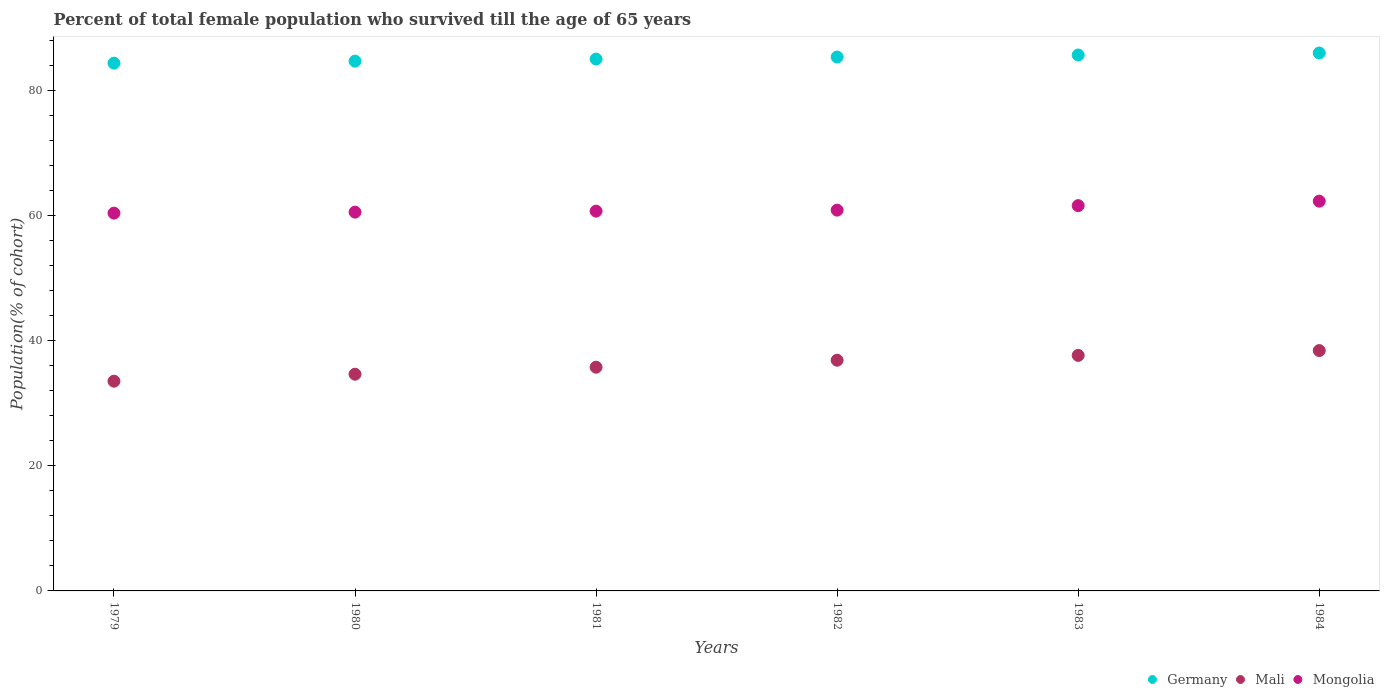What is the percentage of total female population who survived till the age of 65 years in Mongolia in 1982?
Your answer should be compact. 60.85. Across all years, what is the maximum percentage of total female population who survived till the age of 65 years in Germany?
Give a very brief answer. 85.96. Across all years, what is the minimum percentage of total female population who survived till the age of 65 years in Mongolia?
Provide a short and direct response. 60.37. In which year was the percentage of total female population who survived till the age of 65 years in Mali maximum?
Your answer should be very brief. 1984. In which year was the percentage of total female population who survived till the age of 65 years in Germany minimum?
Your answer should be very brief. 1979. What is the total percentage of total female population who survived till the age of 65 years in Mongolia in the graph?
Your response must be concise. 366.28. What is the difference between the percentage of total female population who survived till the age of 65 years in Mongolia in 1981 and that in 1983?
Make the answer very short. -0.88. What is the difference between the percentage of total female population who survived till the age of 65 years in Germany in 1984 and the percentage of total female population who survived till the age of 65 years in Mongolia in 1981?
Offer a very short reply. 25.27. What is the average percentage of total female population who survived till the age of 65 years in Mongolia per year?
Provide a short and direct response. 61.05. In the year 1980, what is the difference between the percentage of total female population who survived till the age of 65 years in Mongolia and percentage of total female population who survived till the age of 65 years in Germany?
Keep it short and to the point. -24.13. In how many years, is the percentage of total female population who survived till the age of 65 years in Germany greater than 4 %?
Ensure brevity in your answer.  6. What is the ratio of the percentage of total female population who survived till the age of 65 years in Mali in 1979 to that in 1983?
Keep it short and to the point. 0.89. Is the difference between the percentage of total female population who survived till the age of 65 years in Mongolia in 1980 and 1983 greater than the difference between the percentage of total female population who survived till the age of 65 years in Germany in 1980 and 1983?
Provide a succinct answer. No. What is the difference between the highest and the second highest percentage of total female population who survived till the age of 65 years in Mali?
Keep it short and to the point. 0.77. What is the difference between the highest and the lowest percentage of total female population who survived till the age of 65 years in Mongolia?
Provide a short and direct response. 1.91. In how many years, is the percentage of total female population who survived till the age of 65 years in Mali greater than the average percentage of total female population who survived till the age of 65 years in Mali taken over all years?
Offer a very short reply. 3. Is the sum of the percentage of total female population who survived till the age of 65 years in Mali in 1982 and 1983 greater than the maximum percentage of total female population who survived till the age of 65 years in Mongolia across all years?
Provide a short and direct response. Yes. Does the percentage of total female population who survived till the age of 65 years in Germany monotonically increase over the years?
Provide a short and direct response. Yes. Is the percentage of total female population who survived till the age of 65 years in Mali strictly greater than the percentage of total female population who survived till the age of 65 years in Germany over the years?
Provide a short and direct response. No. How many dotlines are there?
Your answer should be very brief. 3. What is the difference between two consecutive major ticks on the Y-axis?
Your response must be concise. 20. Does the graph contain grids?
Your answer should be compact. No. How are the legend labels stacked?
Your answer should be very brief. Horizontal. What is the title of the graph?
Provide a succinct answer. Percent of total female population who survived till the age of 65 years. Does "Swaziland" appear as one of the legend labels in the graph?
Keep it short and to the point. No. What is the label or title of the X-axis?
Your answer should be compact. Years. What is the label or title of the Y-axis?
Your response must be concise. Population(% of cohort). What is the Population(% of cohort) of Germany in 1979?
Make the answer very short. 84.33. What is the Population(% of cohort) in Mali in 1979?
Your response must be concise. 33.51. What is the Population(% of cohort) in Mongolia in 1979?
Ensure brevity in your answer.  60.37. What is the Population(% of cohort) of Germany in 1980?
Provide a short and direct response. 84.66. What is the Population(% of cohort) of Mali in 1980?
Your response must be concise. 34.63. What is the Population(% of cohort) of Mongolia in 1980?
Provide a short and direct response. 60.53. What is the Population(% of cohort) in Germany in 1981?
Your response must be concise. 84.99. What is the Population(% of cohort) in Mali in 1981?
Your answer should be very brief. 35.75. What is the Population(% of cohort) of Mongolia in 1981?
Your answer should be very brief. 60.69. What is the Population(% of cohort) of Germany in 1982?
Ensure brevity in your answer.  85.32. What is the Population(% of cohort) of Mali in 1982?
Provide a succinct answer. 36.86. What is the Population(% of cohort) in Mongolia in 1982?
Provide a short and direct response. 60.85. What is the Population(% of cohort) of Germany in 1983?
Provide a short and direct response. 85.64. What is the Population(% of cohort) in Mali in 1983?
Offer a terse response. 37.64. What is the Population(% of cohort) in Mongolia in 1983?
Offer a terse response. 61.56. What is the Population(% of cohort) of Germany in 1984?
Keep it short and to the point. 85.96. What is the Population(% of cohort) in Mali in 1984?
Keep it short and to the point. 38.41. What is the Population(% of cohort) of Mongolia in 1984?
Offer a terse response. 62.28. Across all years, what is the maximum Population(% of cohort) of Germany?
Give a very brief answer. 85.96. Across all years, what is the maximum Population(% of cohort) of Mali?
Provide a succinct answer. 38.41. Across all years, what is the maximum Population(% of cohort) in Mongolia?
Your answer should be compact. 62.28. Across all years, what is the minimum Population(% of cohort) of Germany?
Your answer should be compact. 84.33. Across all years, what is the minimum Population(% of cohort) of Mali?
Offer a terse response. 33.51. Across all years, what is the minimum Population(% of cohort) of Mongolia?
Your answer should be very brief. 60.37. What is the total Population(% of cohort) of Germany in the graph?
Provide a short and direct response. 510.89. What is the total Population(% of cohort) of Mali in the graph?
Offer a terse response. 216.8. What is the total Population(% of cohort) in Mongolia in the graph?
Make the answer very short. 366.28. What is the difference between the Population(% of cohort) in Germany in 1979 and that in 1980?
Your answer should be compact. -0.33. What is the difference between the Population(% of cohort) of Mali in 1979 and that in 1980?
Your answer should be very brief. -1.12. What is the difference between the Population(% of cohort) in Mongolia in 1979 and that in 1980?
Offer a terse response. -0.16. What is the difference between the Population(% of cohort) in Germany in 1979 and that in 1981?
Your response must be concise. -0.66. What is the difference between the Population(% of cohort) in Mali in 1979 and that in 1981?
Ensure brevity in your answer.  -2.23. What is the difference between the Population(% of cohort) in Mongolia in 1979 and that in 1981?
Your answer should be compact. -0.32. What is the difference between the Population(% of cohort) of Germany in 1979 and that in 1982?
Your response must be concise. -0.98. What is the difference between the Population(% of cohort) of Mali in 1979 and that in 1982?
Offer a terse response. -3.35. What is the difference between the Population(% of cohort) of Mongolia in 1979 and that in 1982?
Your answer should be very brief. -0.48. What is the difference between the Population(% of cohort) in Germany in 1979 and that in 1983?
Make the answer very short. -1.31. What is the difference between the Population(% of cohort) in Mali in 1979 and that in 1983?
Your answer should be compact. -4.12. What is the difference between the Population(% of cohort) in Mongolia in 1979 and that in 1983?
Ensure brevity in your answer.  -1.2. What is the difference between the Population(% of cohort) in Germany in 1979 and that in 1984?
Offer a terse response. -1.63. What is the difference between the Population(% of cohort) of Mali in 1979 and that in 1984?
Your answer should be compact. -4.89. What is the difference between the Population(% of cohort) in Mongolia in 1979 and that in 1984?
Ensure brevity in your answer.  -1.91. What is the difference between the Population(% of cohort) of Germany in 1980 and that in 1981?
Your answer should be very brief. -0.33. What is the difference between the Population(% of cohort) in Mali in 1980 and that in 1981?
Offer a very short reply. -1.12. What is the difference between the Population(% of cohort) of Mongolia in 1980 and that in 1981?
Keep it short and to the point. -0.16. What is the difference between the Population(% of cohort) in Germany in 1980 and that in 1982?
Offer a terse response. -0.66. What is the difference between the Population(% of cohort) of Mali in 1980 and that in 1982?
Make the answer very short. -2.23. What is the difference between the Population(% of cohort) in Mongolia in 1980 and that in 1982?
Make the answer very short. -0.32. What is the difference between the Population(% of cohort) of Germany in 1980 and that in 1983?
Provide a succinct answer. -0.98. What is the difference between the Population(% of cohort) in Mali in 1980 and that in 1983?
Offer a very short reply. -3.01. What is the difference between the Population(% of cohort) of Mongolia in 1980 and that in 1983?
Offer a very short reply. -1.04. What is the difference between the Population(% of cohort) of Germany in 1980 and that in 1984?
Ensure brevity in your answer.  -1.3. What is the difference between the Population(% of cohort) of Mali in 1980 and that in 1984?
Offer a terse response. -3.78. What is the difference between the Population(% of cohort) of Mongolia in 1980 and that in 1984?
Provide a succinct answer. -1.75. What is the difference between the Population(% of cohort) of Germany in 1981 and that in 1982?
Give a very brief answer. -0.33. What is the difference between the Population(% of cohort) in Mali in 1981 and that in 1982?
Provide a succinct answer. -1.12. What is the difference between the Population(% of cohort) of Mongolia in 1981 and that in 1982?
Offer a terse response. -0.16. What is the difference between the Population(% of cohort) in Germany in 1981 and that in 1983?
Make the answer very short. -0.65. What is the difference between the Population(% of cohort) in Mali in 1981 and that in 1983?
Your answer should be very brief. -1.89. What is the difference between the Population(% of cohort) of Mongolia in 1981 and that in 1983?
Ensure brevity in your answer.  -0.88. What is the difference between the Population(% of cohort) in Germany in 1981 and that in 1984?
Your answer should be very brief. -0.97. What is the difference between the Population(% of cohort) of Mali in 1981 and that in 1984?
Ensure brevity in your answer.  -2.66. What is the difference between the Population(% of cohort) of Mongolia in 1981 and that in 1984?
Your answer should be compact. -1.59. What is the difference between the Population(% of cohort) of Germany in 1982 and that in 1983?
Provide a succinct answer. -0.32. What is the difference between the Population(% of cohort) in Mali in 1982 and that in 1983?
Ensure brevity in your answer.  -0.77. What is the difference between the Population(% of cohort) of Mongolia in 1982 and that in 1983?
Make the answer very short. -0.72. What is the difference between the Population(% of cohort) of Germany in 1982 and that in 1984?
Provide a succinct answer. -0.64. What is the difference between the Population(% of cohort) in Mali in 1982 and that in 1984?
Your answer should be compact. -1.54. What is the difference between the Population(% of cohort) in Mongolia in 1982 and that in 1984?
Keep it short and to the point. -1.43. What is the difference between the Population(% of cohort) in Germany in 1983 and that in 1984?
Your answer should be very brief. -0.32. What is the difference between the Population(% of cohort) of Mali in 1983 and that in 1984?
Your response must be concise. -0.77. What is the difference between the Population(% of cohort) of Mongolia in 1983 and that in 1984?
Your answer should be compact. -0.72. What is the difference between the Population(% of cohort) of Germany in 1979 and the Population(% of cohort) of Mali in 1980?
Your answer should be compact. 49.7. What is the difference between the Population(% of cohort) of Germany in 1979 and the Population(% of cohort) of Mongolia in 1980?
Your answer should be very brief. 23.8. What is the difference between the Population(% of cohort) in Mali in 1979 and the Population(% of cohort) in Mongolia in 1980?
Your answer should be compact. -27.01. What is the difference between the Population(% of cohort) in Germany in 1979 and the Population(% of cohort) in Mali in 1981?
Your answer should be compact. 48.58. What is the difference between the Population(% of cohort) in Germany in 1979 and the Population(% of cohort) in Mongolia in 1981?
Provide a succinct answer. 23.64. What is the difference between the Population(% of cohort) in Mali in 1979 and the Population(% of cohort) in Mongolia in 1981?
Ensure brevity in your answer.  -27.18. What is the difference between the Population(% of cohort) in Germany in 1979 and the Population(% of cohort) in Mali in 1982?
Keep it short and to the point. 47.47. What is the difference between the Population(% of cohort) in Germany in 1979 and the Population(% of cohort) in Mongolia in 1982?
Your answer should be compact. 23.48. What is the difference between the Population(% of cohort) of Mali in 1979 and the Population(% of cohort) of Mongolia in 1982?
Provide a succinct answer. -27.34. What is the difference between the Population(% of cohort) of Germany in 1979 and the Population(% of cohort) of Mali in 1983?
Your answer should be very brief. 46.7. What is the difference between the Population(% of cohort) of Germany in 1979 and the Population(% of cohort) of Mongolia in 1983?
Make the answer very short. 22.77. What is the difference between the Population(% of cohort) of Mali in 1979 and the Population(% of cohort) of Mongolia in 1983?
Ensure brevity in your answer.  -28.05. What is the difference between the Population(% of cohort) in Germany in 1979 and the Population(% of cohort) in Mali in 1984?
Keep it short and to the point. 45.92. What is the difference between the Population(% of cohort) of Germany in 1979 and the Population(% of cohort) of Mongolia in 1984?
Your response must be concise. 22.05. What is the difference between the Population(% of cohort) in Mali in 1979 and the Population(% of cohort) in Mongolia in 1984?
Ensure brevity in your answer.  -28.77. What is the difference between the Population(% of cohort) of Germany in 1980 and the Population(% of cohort) of Mali in 1981?
Make the answer very short. 48.91. What is the difference between the Population(% of cohort) in Germany in 1980 and the Population(% of cohort) in Mongolia in 1981?
Give a very brief answer. 23.97. What is the difference between the Population(% of cohort) in Mali in 1980 and the Population(% of cohort) in Mongolia in 1981?
Keep it short and to the point. -26.06. What is the difference between the Population(% of cohort) of Germany in 1980 and the Population(% of cohort) of Mali in 1982?
Your answer should be compact. 47.79. What is the difference between the Population(% of cohort) in Germany in 1980 and the Population(% of cohort) in Mongolia in 1982?
Make the answer very short. 23.81. What is the difference between the Population(% of cohort) in Mali in 1980 and the Population(% of cohort) in Mongolia in 1982?
Give a very brief answer. -26.22. What is the difference between the Population(% of cohort) in Germany in 1980 and the Population(% of cohort) in Mali in 1983?
Your answer should be very brief. 47.02. What is the difference between the Population(% of cohort) in Germany in 1980 and the Population(% of cohort) in Mongolia in 1983?
Provide a succinct answer. 23.09. What is the difference between the Population(% of cohort) in Mali in 1980 and the Population(% of cohort) in Mongolia in 1983?
Offer a terse response. -26.93. What is the difference between the Population(% of cohort) in Germany in 1980 and the Population(% of cohort) in Mali in 1984?
Your response must be concise. 46.25. What is the difference between the Population(% of cohort) in Germany in 1980 and the Population(% of cohort) in Mongolia in 1984?
Make the answer very short. 22.38. What is the difference between the Population(% of cohort) of Mali in 1980 and the Population(% of cohort) of Mongolia in 1984?
Provide a short and direct response. -27.65. What is the difference between the Population(% of cohort) in Germany in 1981 and the Population(% of cohort) in Mali in 1982?
Your answer should be compact. 48.12. What is the difference between the Population(% of cohort) in Germany in 1981 and the Population(% of cohort) in Mongolia in 1982?
Provide a succinct answer. 24.14. What is the difference between the Population(% of cohort) in Mali in 1981 and the Population(% of cohort) in Mongolia in 1982?
Your answer should be very brief. -25.1. What is the difference between the Population(% of cohort) of Germany in 1981 and the Population(% of cohort) of Mali in 1983?
Your answer should be compact. 47.35. What is the difference between the Population(% of cohort) of Germany in 1981 and the Population(% of cohort) of Mongolia in 1983?
Ensure brevity in your answer.  23.42. What is the difference between the Population(% of cohort) of Mali in 1981 and the Population(% of cohort) of Mongolia in 1983?
Keep it short and to the point. -25.82. What is the difference between the Population(% of cohort) of Germany in 1981 and the Population(% of cohort) of Mali in 1984?
Offer a terse response. 46.58. What is the difference between the Population(% of cohort) of Germany in 1981 and the Population(% of cohort) of Mongolia in 1984?
Provide a succinct answer. 22.71. What is the difference between the Population(% of cohort) in Mali in 1981 and the Population(% of cohort) in Mongolia in 1984?
Keep it short and to the point. -26.53. What is the difference between the Population(% of cohort) in Germany in 1982 and the Population(% of cohort) in Mali in 1983?
Offer a very short reply. 47.68. What is the difference between the Population(% of cohort) in Germany in 1982 and the Population(% of cohort) in Mongolia in 1983?
Keep it short and to the point. 23.75. What is the difference between the Population(% of cohort) of Mali in 1982 and the Population(% of cohort) of Mongolia in 1983?
Make the answer very short. -24.7. What is the difference between the Population(% of cohort) in Germany in 1982 and the Population(% of cohort) in Mali in 1984?
Give a very brief answer. 46.91. What is the difference between the Population(% of cohort) in Germany in 1982 and the Population(% of cohort) in Mongolia in 1984?
Give a very brief answer. 23.03. What is the difference between the Population(% of cohort) in Mali in 1982 and the Population(% of cohort) in Mongolia in 1984?
Make the answer very short. -25.42. What is the difference between the Population(% of cohort) in Germany in 1983 and the Population(% of cohort) in Mali in 1984?
Keep it short and to the point. 47.23. What is the difference between the Population(% of cohort) of Germany in 1983 and the Population(% of cohort) of Mongolia in 1984?
Ensure brevity in your answer.  23.36. What is the difference between the Population(% of cohort) in Mali in 1983 and the Population(% of cohort) in Mongolia in 1984?
Provide a succinct answer. -24.65. What is the average Population(% of cohort) in Germany per year?
Your answer should be compact. 85.15. What is the average Population(% of cohort) of Mali per year?
Your answer should be very brief. 36.13. What is the average Population(% of cohort) of Mongolia per year?
Give a very brief answer. 61.05. In the year 1979, what is the difference between the Population(% of cohort) in Germany and Population(% of cohort) in Mali?
Make the answer very short. 50.82. In the year 1979, what is the difference between the Population(% of cohort) of Germany and Population(% of cohort) of Mongolia?
Your response must be concise. 23.96. In the year 1979, what is the difference between the Population(% of cohort) of Mali and Population(% of cohort) of Mongolia?
Provide a short and direct response. -26.85. In the year 1980, what is the difference between the Population(% of cohort) in Germany and Population(% of cohort) in Mali?
Your answer should be compact. 50.03. In the year 1980, what is the difference between the Population(% of cohort) in Germany and Population(% of cohort) in Mongolia?
Offer a terse response. 24.13. In the year 1980, what is the difference between the Population(% of cohort) in Mali and Population(% of cohort) in Mongolia?
Your answer should be compact. -25.9. In the year 1981, what is the difference between the Population(% of cohort) in Germany and Population(% of cohort) in Mali?
Make the answer very short. 49.24. In the year 1981, what is the difference between the Population(% of cohort) of Germany and Population(% of cohort) of Mongolia?
Provide a short and direct response. 24.3. In the year 1981, what is the difference between the Population(% of cohort) in Mali and Population(% of cohort) in Mongolia?
Ensure brevity in your answer.  -24.94. In the year 1982, what is the difference between the Population(% of cohort) of Germany and Population(% of cohort) of Mali?
Ensure brevity in your answer.  48.45. In the year 1982, what is the difference between the Population(% of cohort) in Germany and Population(% of cohort) in Mongolia?
Keep it short and to the point. 24.47. In the year 1982, what is the difference between the Population(% of cohort) of Mali and Population(% of cohort) of Mongolia?
Provide a short and direct response. -23.98. In the year 1983, what is the difference between the Population(% of cohort) of Germany and Population(% of cohort) of Mali?
Your answer should be very brief. 48. In the year 1983, what is the difference between the Population(% of cohort) in Germany and Population(% of cohort) in Mongolia?
Ensure brevity in your answer.  24.07. In the year 1983, what is the difference between the Population(% of cohort) of Mali and Population(% of cohort) of Mongolia?
Provide a short and direct response. -23.93. In the year 1984, what is the difference between the Population(% of cohort) in Germany and Population(% of cohort) in Mali?
Provide a short and direct response. 47.55. In the year 1984, what is the difference between the Population(% of cohort) in Germany and Population(% of cohort) in Mongolia?
Your answer should be compact. 23.68. In the year 1984, what is the difference between the Population(% of cohort) in Mali and Population(% of cohort) in Mongolia?
Your answer should be compact. -23.87. What is the ratio of the Population(% of cohort) of Mali in 1979 to that in 1980?
Provide a succinct answer. 0.97. What is the ratio of the Population(% of cohort) of Germany in 1979 to that in 1981?
Offer a terse response. 0.99. What is the ratio of the Population(% of cohort) of Mali in 1979 to that in 1981?
Your response must be concise. 0.94. What is the ratio of the Population(% of cohort) in Germany in 1979 to that in 1982?
Your answer should be compact. 0.99. What is the ratio of the Population(% of cohort) in Mali in 1979 to that in 1982?
Your answer should be compact. 0.91. What is the ratio of the Population(% of cohort) of Germany in 1979 to that in 1983?
Your answer should be compact. 0.98. What is the ratio of the Population(% of cohort) of Mali in 1979 to that in 1983?
Provide a short and direct response. 0.89. What is the ratio of the Population(% of cohort) of Mongolia in 1979 to that in 1983?
Your answer should be very brief. 0.98. What is the ratio of the Population(% of cohort) in Germany in 1979 to that in 1984?
Your answer should be very brief. 0.98. What is the ratio of the Population(% of cohort) in Mali in 1979 to that in 1984?
Ensure brevity in your answer.  0.87. What is the ratio of the Population(% of cohort) in Mongolia in 1979 to that in 1984?
Your answer should be very brief. 0.97. What is the ratio of the Population(% of cohort) of Germany in 1980 to that in 1981?
Ensure brevity in your answer.  1. What is the ratio of the Population(% of cohort) in Mali in 1980 to that in 1981?
Give a very brief answer. 0.97. What is the ratio of the Population(% of cohort) in Mongolia in 1980 to that in 1981?
Your answer should be very brief. 1. What is the ratio of the Population(% of cohort) of Mali in 1980 to that in 1982?
Make the answer very short. 0.94. What is the ratio of the Population(% of cohort) of Germany in 1980 to that in 1983?
Ensure brevity in your answer.  0.99. What is the ratio of the Population(% of cohort) in Mali in 1980 to that in 1983?
Provide a succinct answer. 0.92. What is the ratio of the Population(% of cohort) in Mongolia in 1980 to that in 1983?
Ensure brevity in your answer.  0.98. What is the ratio of the Population(% of cohort) in Germany in 1980 to that in 1984?
Your answer should be compact. 0.98. What is the ratio of the Population(% of cohort) in Mali in 1980 to that in 1984?
Provide a succinct answer. 0.9. What is the ratio of the Population(% of cohort) in Mongolia in 1980 to that in 1984?
Make the answer very short. 0.97. What is the ratio of the Population(% of cohort) in Germany in 1981 to that in 1982?
Make the answer very short. 1. What is the ratio of the Population(% of cohort) in Mali in 1981 to that in 1982?
Provide a short and direct response. 0.97. What is the ratio of the Population(% of cohort) in Mongolia in 1981 to that in 1982?
Provide a short and direct response. 1. What is the ratio of the Population(% of cohort) of Mali in 1981 to that in 1983?
Keep it short and to the point. 0.95. What is the ratio of the Population(% of cohort) in Mongolia in 1981 to that in 1983?
Provide a succinct answer. 0.99. What is the ratio of the Population(% of cohort) of Germany in 1981 to that in 1984?
Offer a terse response. 0.99. What is the ratio of the Population(% of cohort) of Mali in 1981 to that in 1984?
Give a very brief answer. 0.93. What is the ratio of the Population(% of cohort) in Mongolia in 1981 to that in 1984?
Keep it short and to the point. 0.97. What is the ratio of the Population(% of cohort) in Germany in 1982 to that in 1983?
Provide a succinct answer. 1. What is the ratio of the Population(% of cohort) of Mali in 1982 to that in 1983?
Your answer should be very brief. 0.98. What is the ratio of the Population(% of cohort) of Mongolia in 1982 to that in 1983?
Offer a very short reply. 0.99. What is the ratio of the Population(% of cohort) of Mali in 1982 to that in 1984?
Offer a terse response. 0.96. What is the ratio of the Population(% of cohort) in Mongolia in 1982 to that in 1984?
Ensure brevity in your answer.  0.98. What is the ratio of the Population(% of cohort) in Mali in 1983 to that in 1984?
Your response must be concise. 0.98. What is the ratio of the Population(% of cohort) in Mongolia in 1983 to that in 1984?
Keep it short and to the point. 0.99. What is the difference between the highest and the second highest Population(% of cohort) in Germany?
Make the answer very short. 0.32. What is the difference between the highest and the second highest Population(% of cohort) in Mali?
Give a very brief answer. 0.77. What is the difference between the highest and the second highest Population(% of cohort) in Mongolia?
Offer a very short reply. 0.72. What is the difference between the highest and the lowest Population(% of cohort) in Germany?
Make the answer very short. 1.63. What is the difference between the highest and the lowest Population(% of cohort) in Mali?
Make the answer very short. 4.89. What is the difference between the highest and the lowest Population(% of cohort) in Mongolia?
Ensure brevity in your answer.  1.91. 